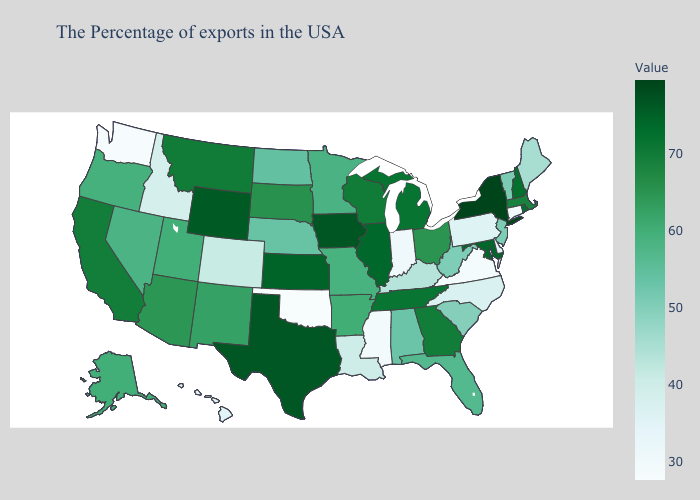Which states have the lowest value in the USA?
Write a very short answer. Oklahoma. Does Iowa have the lowest value in the USA?
Write a very short answer. No. Among the states that border Arkansas , does Mississippi have the highest value?
Be succinct. No. Among the states that border Michigan , does Indiana have the lowest value?
Short answer required. Yes. Does Illinois have the lowest value in the USA?
Give a very brief answer. No. Does the map have missing data?
Be succinct. No. Among the states that border Indiana , which have the lowest value?
Write a very short answer. Kentucky. Which states have the highest value in the USA?
Keep it brief. New York. 